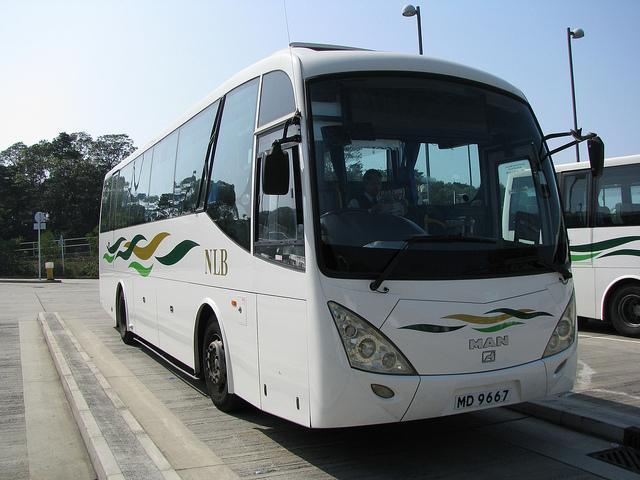What country does this bus originate from?
Choose the correct response, then elucidate: 'Answer: answer
Rationale: rationale.'
Options: Italy, russia, germany, hong kong. Answer: hong kong.
Rationale: This bus is from hong kong. 